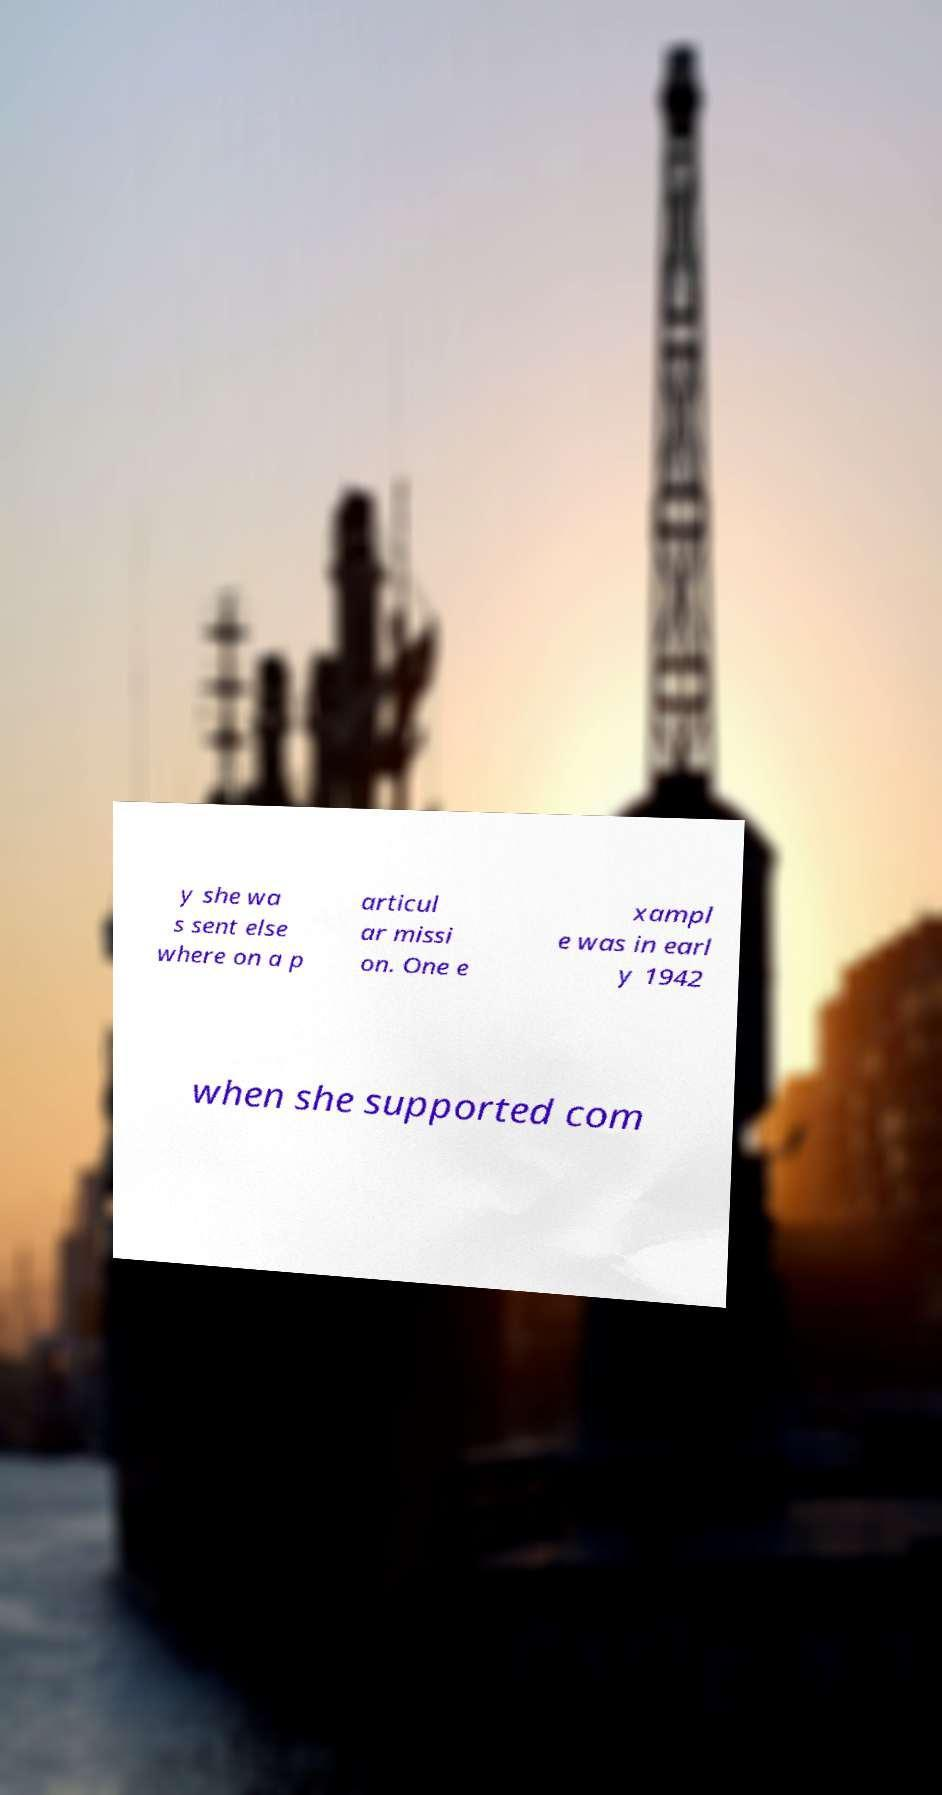For documentation purposes, I need the text within this image transcribed. Could you provide that? y she wa s sent else where on a p articul ar missi on. One e xampl e was in earl y 1942 when she supported com 